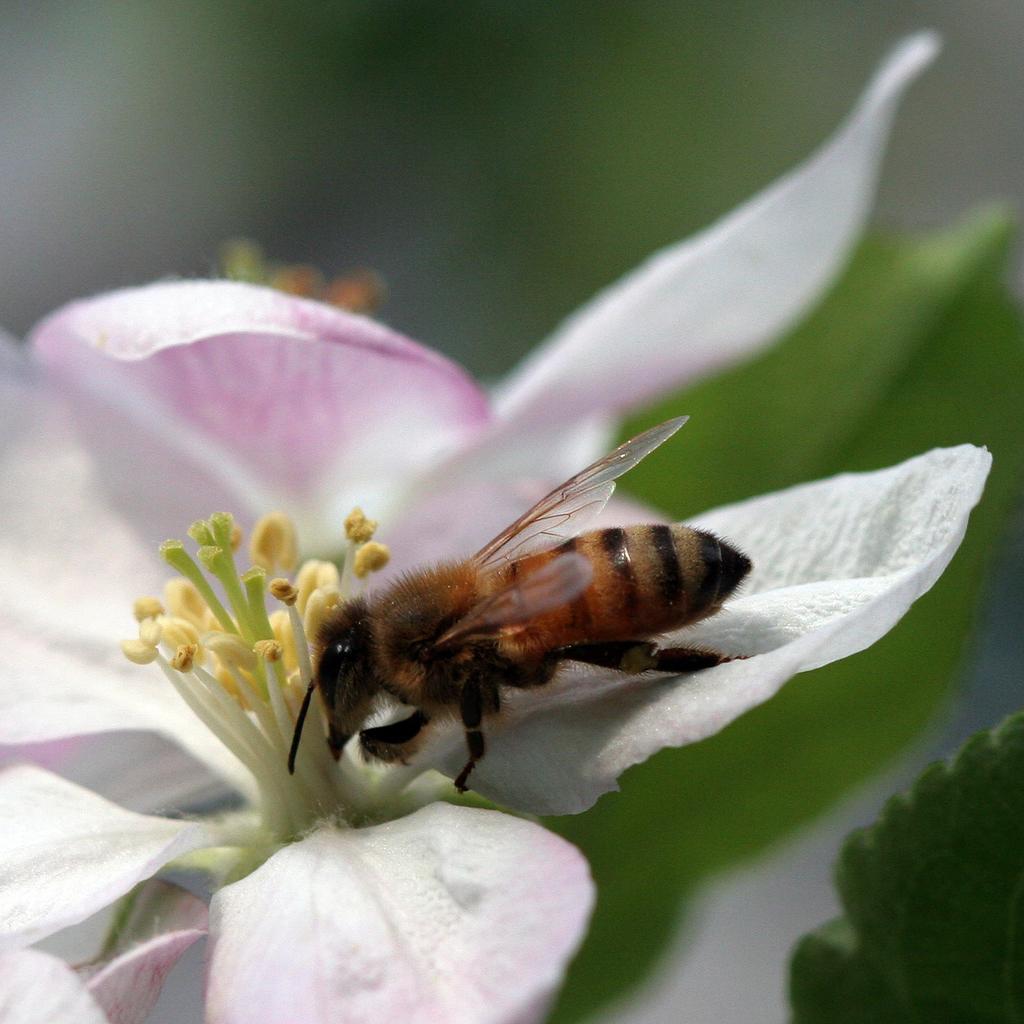Please provide a concise description of this image. In the center of the image, we can see a bee on the flower and in the background, there are leaves. 